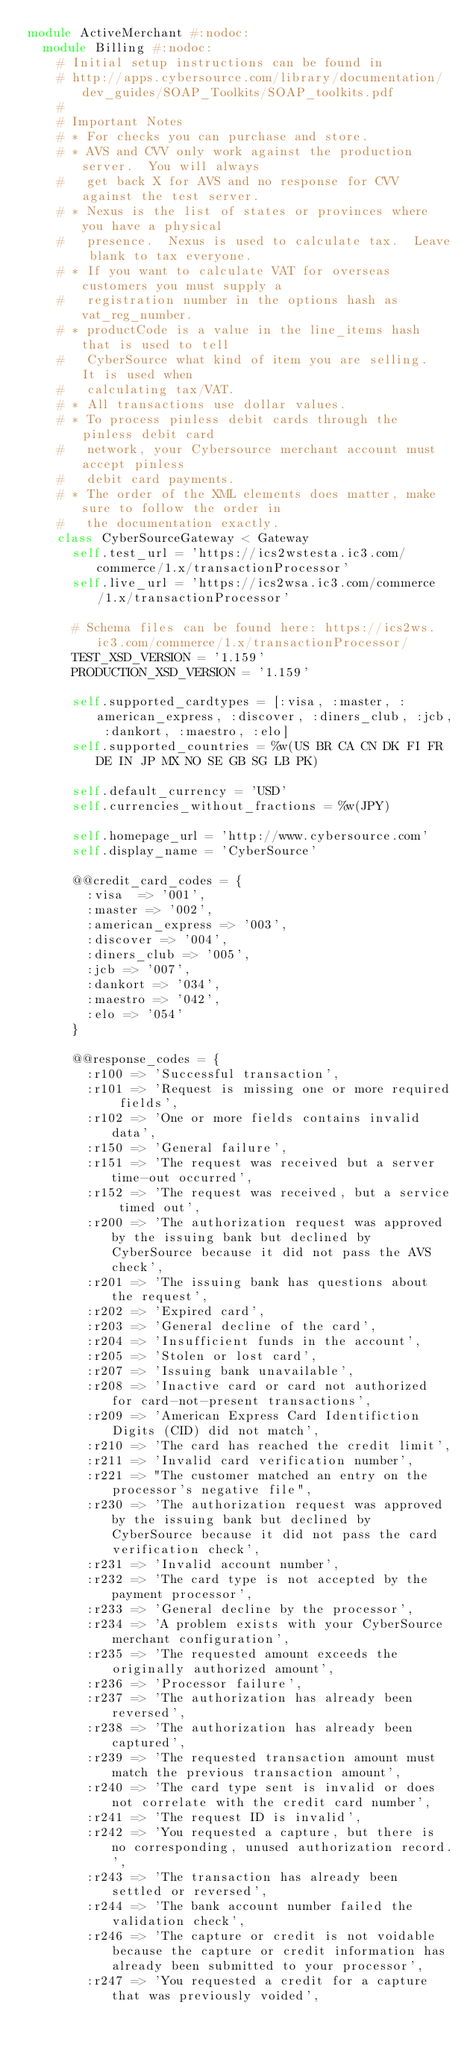Convert code to text. <code><loc_0><loc_0><loc_500><loc_500><_Ruby_>module ActiveMerchant #:nodoc:
  module Billing #:nodoc:
    # Initial setup instructions can be found in
    # http://apps.cybersource.com/library/documentation/dev_guides/SOAP_Toolkits/SOAP_toolkits.pdf
    #
    # Important Notes
    # * For checks you can purchase and store.
    # * AVS and CVV only work against the production server.  You will always
    #   get back X for AVS and no response for CVV against the test server.
    # * Nexus is the list of states or provinces where you have a physical
    #   presence.  Nexus is used to calculate tax.  Leave blank to tax everyone.
    # * If you want to calculate VAT for overseas customers you must supply a
    #   registration number in the options hash as vat_reg_number.
    # * productCode is a value in the line_items hash that is used to tell
    #   CyberSource what kind of item you are selling.  It is used when
    #   calculating tax/VAT.
    # * All transactions use dollar values.
    # * To process pinless debit cards through the pinless debit card
    #   network, your Cybersource merchant account must accept pinless
    #   debit card payments.
    # * The order of the XML elements does matter, make sure to follow the order in
    #   the documentation exactly.
    class CyberSourceGateway < Gateway
      self.test_url = 'https://ics2wstesta.ic3.com/commerce/1.x/transactionProcessor'
      self.live_url = 'https://ics2wsa.ic3.com/commerce/1.x/transactionProcessor'

      # Schema files can be found here: https://ics2ws.ic3.com/commerce/1.x/transactionProcessor/
      TEST_XSD_VERSION = '1.159'
      PRODUCTION_XSD_VERSION = '1.159'

      self.supported_cardtypes = [:visa, :master, :american_express, :discover, :diners_club, :jcb, :dankort, :maestro, :elo]
      self.supported_countries = %w(US BR CA CN DK FI FR DE IN JP MX NO SE GB SG LB PK)

      self.default_currency = 'USD'
      self.currencies_without_fractions = %w(JPY)

      self.homepage_url = 'http://www.cybersource.com'
      self.display_name = 'CyberSource'

      @@credit_card_codes = {
        :visa  => '001',
        :master => '002',
        :american_express => '003',
        :discover => '004',
        :diners_club => '005',
        :jcb => '007',
        :dankort => '034',
        :maestro => '042',
        :elo => '054'
      }

      @@response_codes = {
        :r100 => 'Successful transaction',
        :r101 => 'Request is missing one or more required fields',
        :r102 => 'One or more fields contains invalid data',
        :r150 => 'General failure',
        :r151 => 'The request was received but a server time-out occurred',
        :r152 => 'The request was received, but a service timed out',
        :r200 => 'The authorization request was approved by the issuing bank but declined by CyberSource because it did not pass the AVS check',
        :r201 => 'The issuing bank has questions about the request',
        :r202 => 'Expired card',
        :r203 => 'General decline of the card',
        :r204 => 'Insufficient funds in the account',
        :r205 => 'Stolen or lost card',
        :r207 => 'Issuing bank unavailable',
        :r208 => 'Inactive card or card not authorized for card-not-present transactions',
        :r209 => 'American Express Card Identifiction Digits (CID) did not match',
        :r210 => 'The card has reached the credit limit',
        :r211 => 'Invalid card verification number',
        :r221 => "The customer matched an entry on the processor's negative file",
        :r230 => 'The authorization request was approved by the issuing bank but declined by CyberSource because it did not pass the card verification check',
        :r231 => 'Invalid account number',
        :r232 => 'The card type is not accepted by the payment processor',
        :r233 => 'General decline by the processor',
        :r234 => 'A problem exists with your CyberSource merchant configuration',
        :r235 => 'The requested amount exceeds the originally authorized amount',
        :r236 => 'Processor failure',
        :r237 => 'The authorization has already been reversed',
        :r238 => 'The authorization has already been captured',
        :r239 => 'The requested transaction amount must match the previous transaction amount',
        :r240 => 'The card type sent is invalid or does not correlate with the credit card number',
        :r241 => 'The request ID is invalid',
        :r242 => 'You requested a capture, but there is no corresponding, unused authorization record.',
        :r243 => 'The transaction has already been settled or reversed',
        :r244 => 'The bank account number failed the validation check',
        :r246 => 'The capture or credit is not voidable because the capture or credit information has already been submitted to your processor',
        :r247 => 'You requested a credit for a capture that was previously voided',</code> 